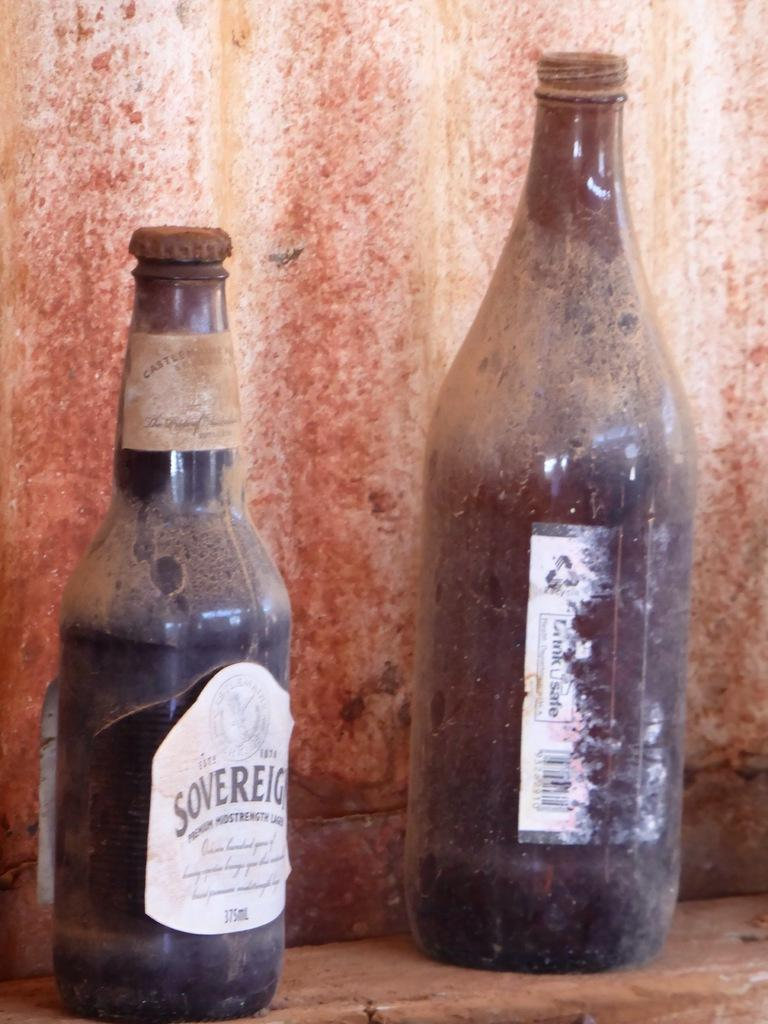<image>
Write a terse but informative summary of the picture. A bottle of Sovereign is on a wooden surface next to an indistinguishable dirty bottle. 